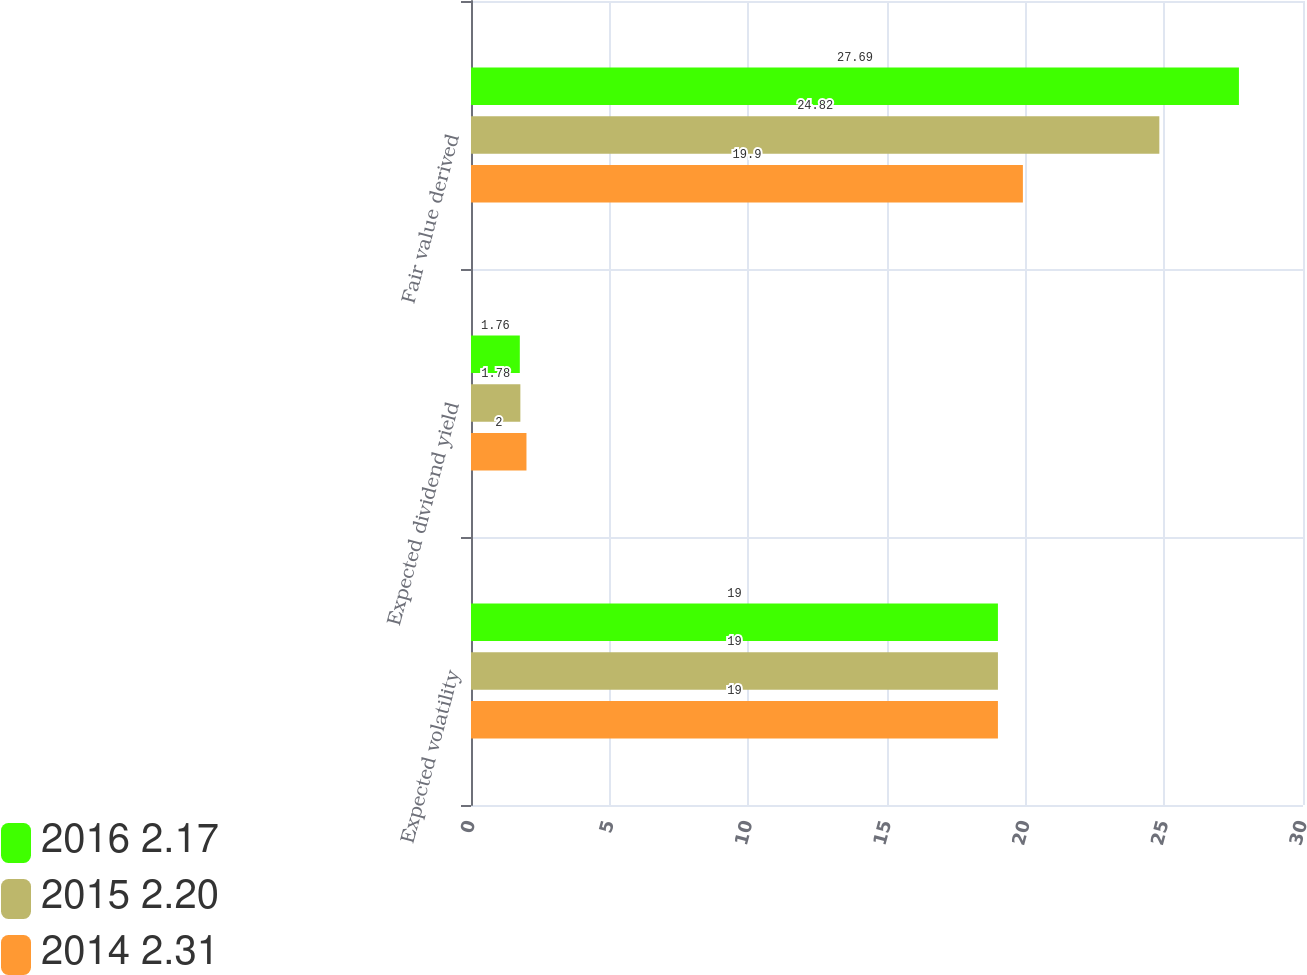Convert chart. <chart><loc_0><loc_0><loc_500><loc_500><stacked_bar_chart><ecel><fcel>Expected volatility<fcel>Expected dividend yield<fcel>Fair value derived<nl><fcel>2016 2.17<fcel>19<fcel>1.76<fcel>27.69<nl><fcel>2015 2.20<fcel>19<fcel>1.78<fcel>24.82<nl><fcel>2014 2.31<fcel>19<fcel>2<fcel>19.9<nl></chart> 